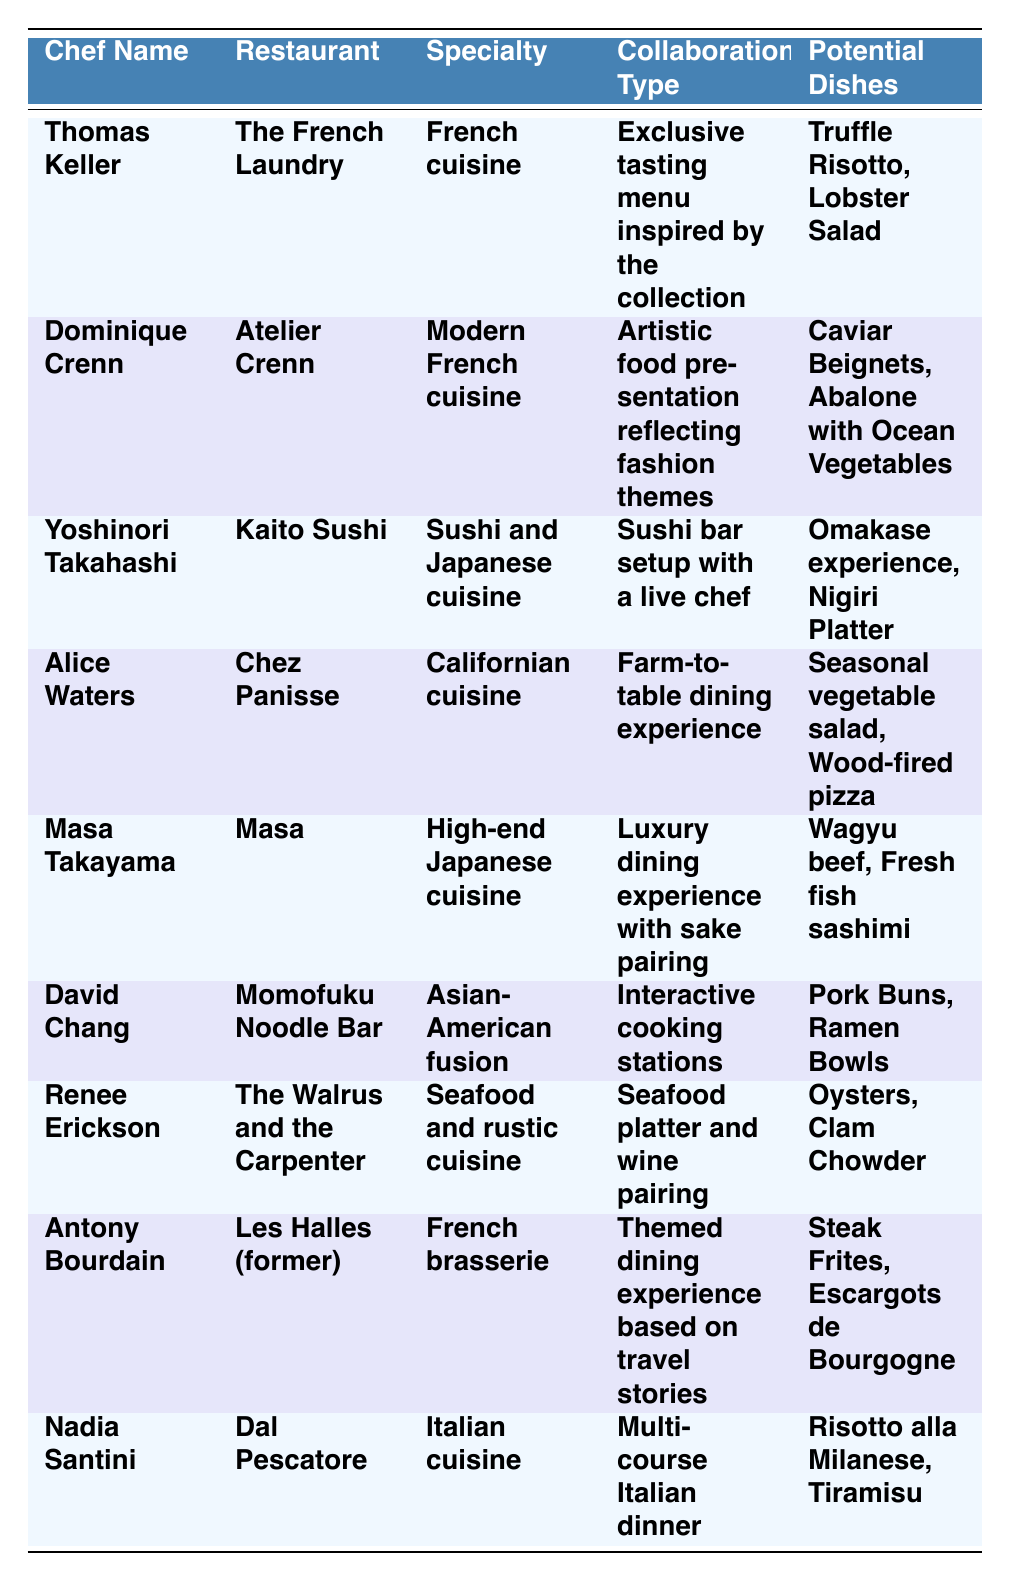What type of cuisine does Thomas Keller specialize in? The table indicates that Thomas Keller specializes in "French cuisine" under the "Specialty" column.
Answer: French cuisine What is the collaboration type offered by Alice Waters? According to the table, Alice Waters offers a "Farm-to-table dining experience" under the "Collaboration Type" column.
Answer: Farm-to-table dining experience Which chef's collaboration involves a sushi bar setup with a live chef? The table shows that Yoshinori Takahashi's collaboration involves a "Sushi bar setup with a live chef," which can be found in the "Collaboration Type" column.
Answer: Yoshinori Takahashi List all potential dishes from the collaboration with Dominique Crenn. The "Potential Dishes" column for Dominique Crenn indicates "Caviar Beignets, Abalone with Ocean Vegetables" as the potential dishes for her collaboration.
Answer: Caviar Beignets, Abalone with Ocean Vegetables True or false: David Chang specializes in French brasserie cuisine. The table lists David Chang's specialty as "Asian-American fusion," not French brasserie, making the statement false.
Answer: False Identify the chef who offers an interactive cooking stations collaboration. The table specifies that David Chang offers "Interactive cooking stations" as the collaboration type, which is provided in the "Collaboration Type" column.
Answer: David Chang How many chefs listed have Italian cuisine as their specialty? The table shows that only Nadia Santini has "Italian cuisine" listed as her specialty, therefore there is one chef.
Answer: 1 Which collaboration type from the list is related to travel stories? According to the table, Antony Bourdain's collaboration type is "Themed dining experience based on travel stories."
Answer: Themed dining experience based on travel stories Compare the specialties of Alice Waters and Masa Takayama. Alice Waters specializes in "Californian cuisine," while Masa Takayama specializes in "High-end Japanese cuisine," revealing different culinary focuses.
Answer: Different culinary focuses What are the potential dishes offered in the collaboration with Thomas Keller? The potential dishes listed for Thomas Keller's collaboration are "Truffle Risotto, Lobster Salad," as found in the "Potential Dishes" column.
Answer: Truffle Risotto, Lobster Salad 